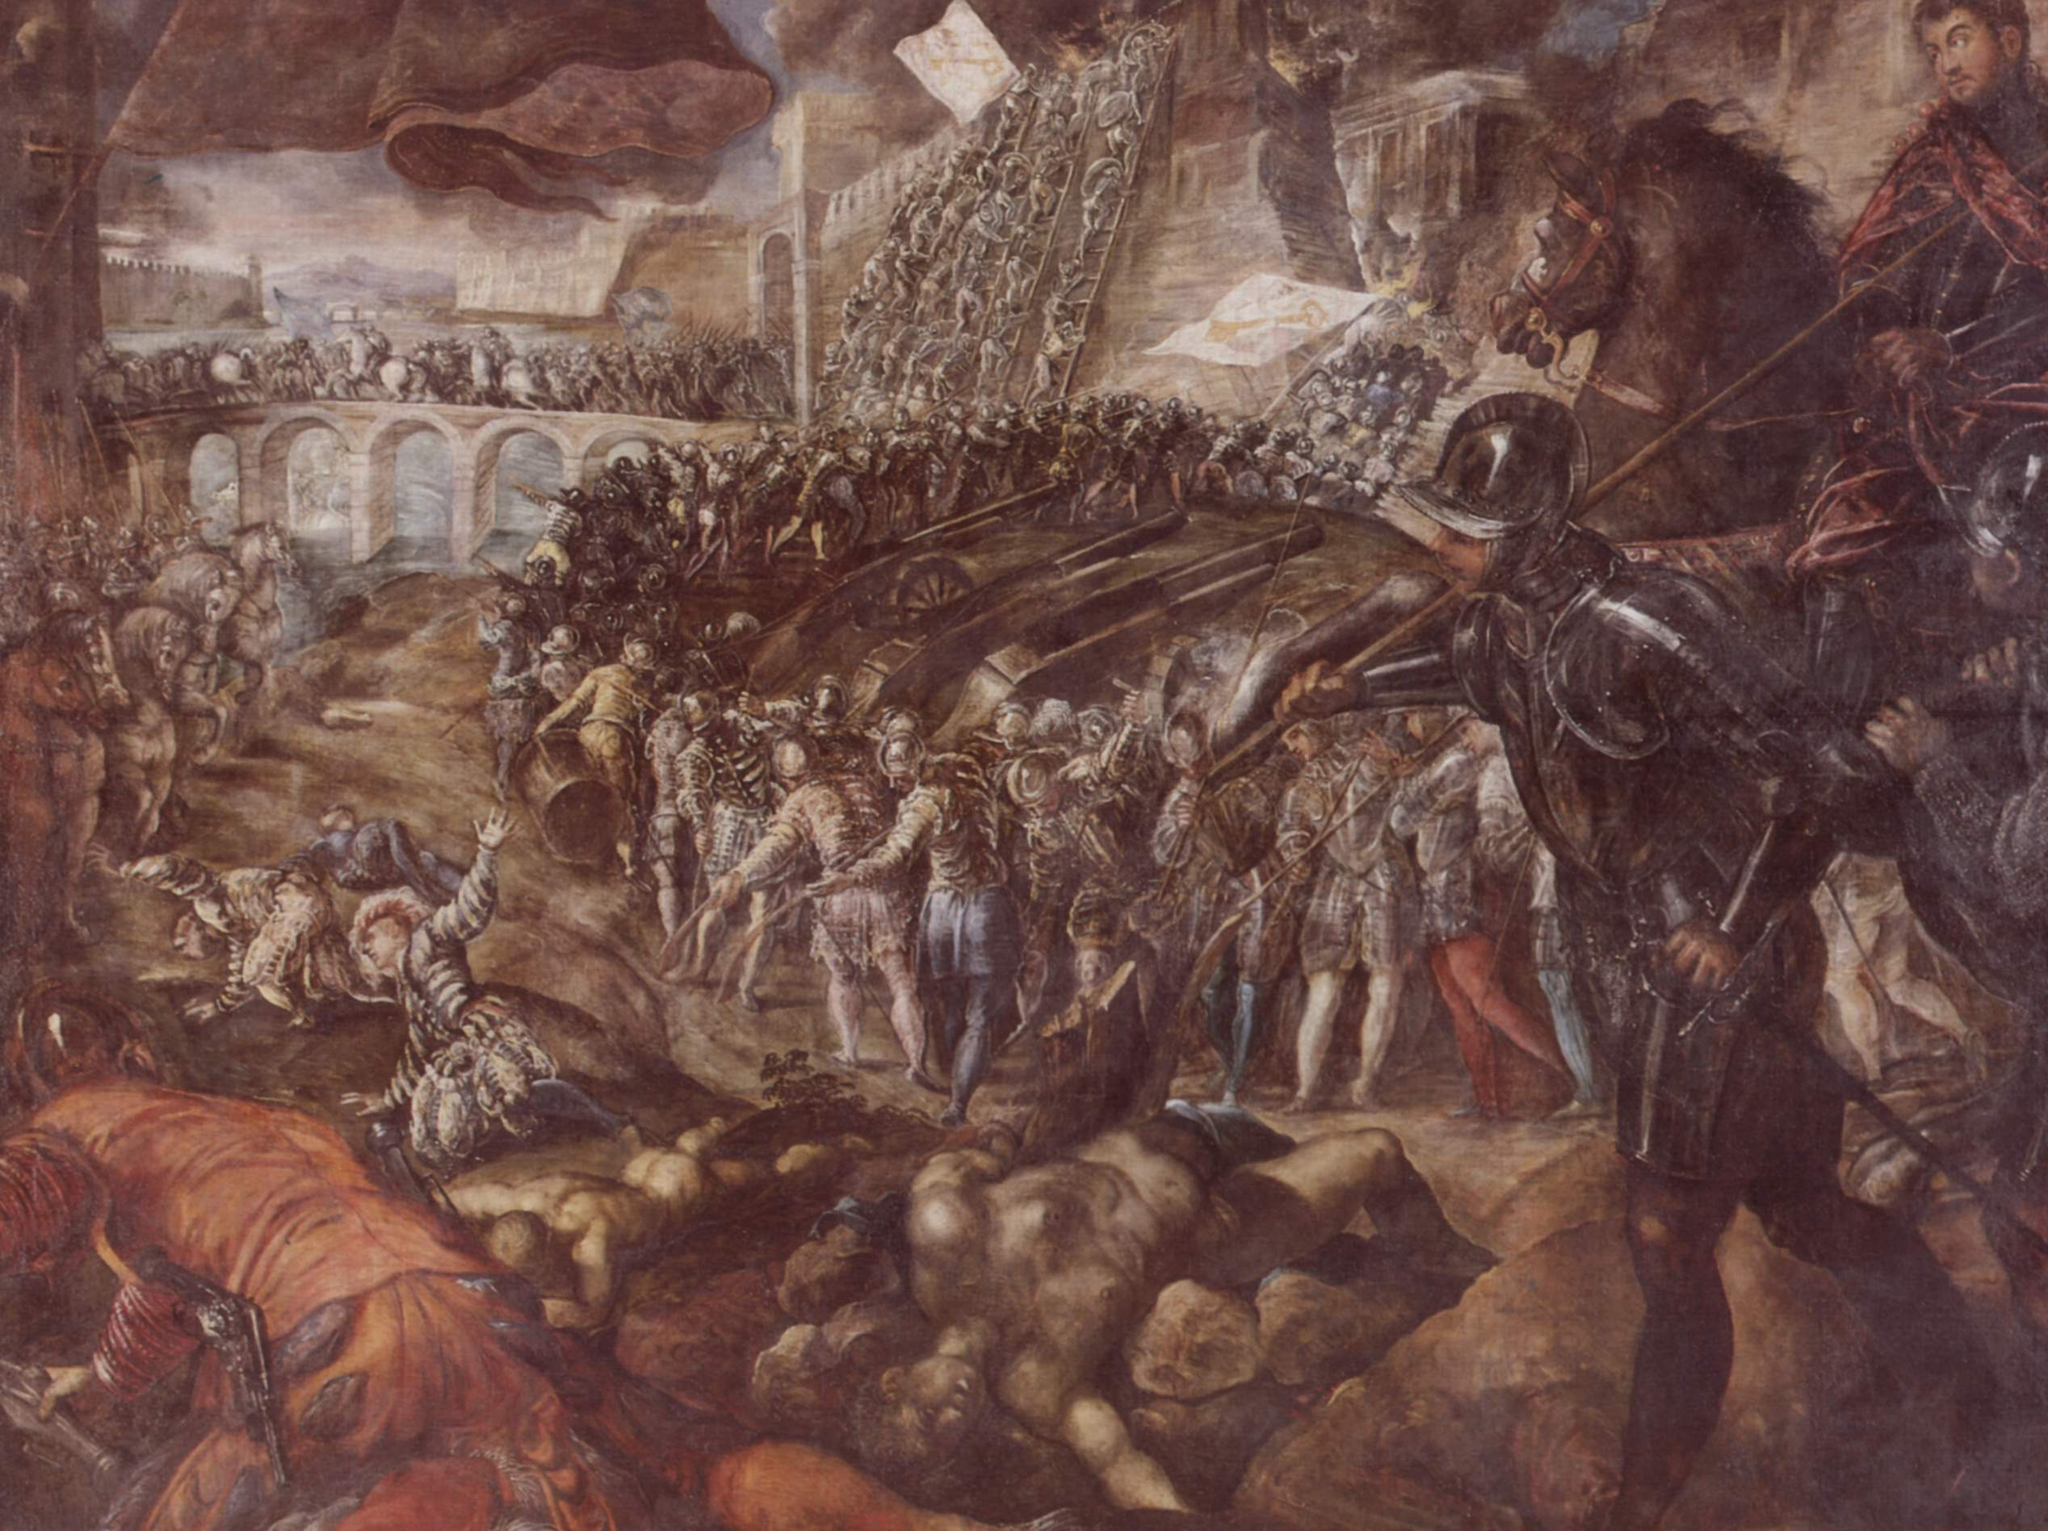How does the color palette affect the mood of the scene? The color palette plays a crucial role in setting the mood of the battle scene. The dominant use of earthy tones, such as browns and ochres, anchors the scene in a gritty realism, suggesting the harsh and brutal reality of war. The subdued colors convey a sense of somberness and tragedy, fitting for the depiction of such a chaotic and violent event. The brighter hues, such as the blue sky, offer a stark contrast that highlights the turmoil below. This contrast enhances the dramatic tension in the image, emphasizing the stark difference between the serenity above and the chaos on the ground. Overall, the palette evokes a feeling of turmoil and conflict, drawing the viewer into the emotional gravity of the scene. 